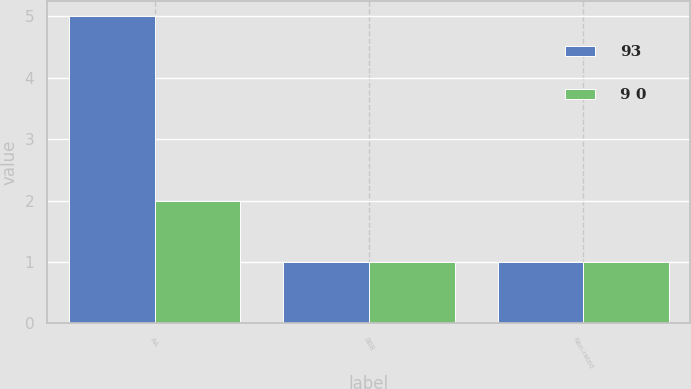Convert chart to OTSL. <chart><loc_0><loc_0><loc_500><loc_500><stacked_bar_chart><ecel><fcel>AA<fcel>BBB<fcel>Non-rated<nl><fcel>93<fcel>5<fcel>1<fcel>1<nl><fcel>9 0<fcel>2<fcel>1<fcel>1<nl></chart> 